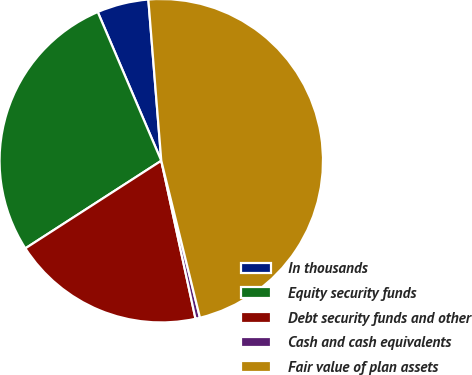<chart> <loc_0><loc_0><loc_500><loc_500><pie_chart><fcel>In thousands<fcel>Equity security funds<fcel>Debt security funds and other<fcel>Cash and cash equivalents<fcel>Fair value of plan assets<nl><fcel>5.15%<fcel>27.69%<fcel>19.28%<fcel>0.45%<fcel>47.43%<nl></chart> 